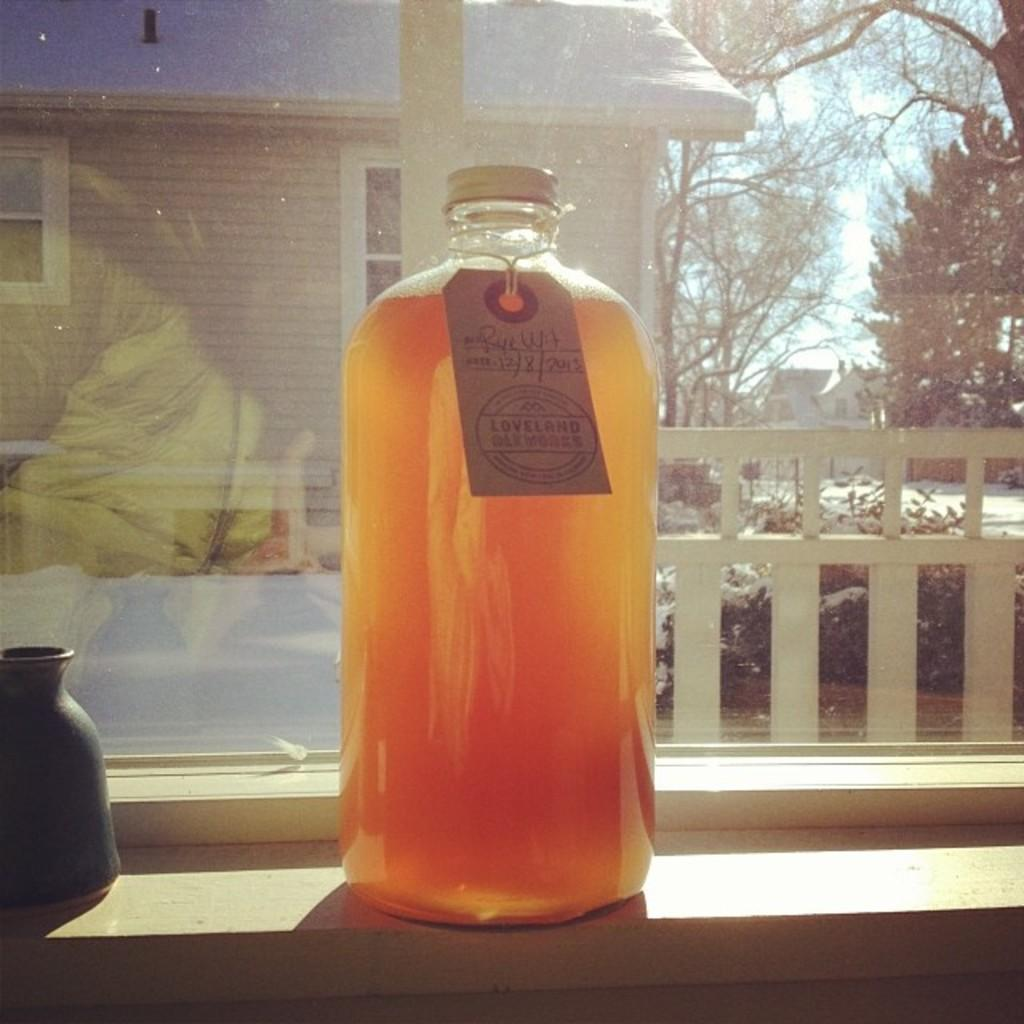<image>
Give a short and clear explanation of the subsequent image. A product inside a glass bottle sits on a windowsill was created on 12/8/2013. 